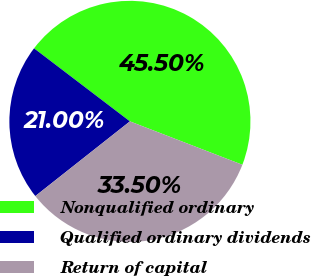<chart> <loc_0><loc_0><loc_500><loc_500><pie_chart><fcel>Nonqualified ordinary<fcel>Qualified ordinary dividends<fcel>Return of capital<nl><fcel>45.5%<fcel>21.0%<fcel>33.5%<nl></chart> 